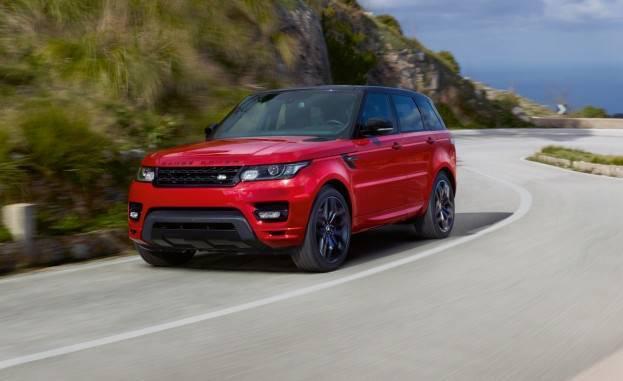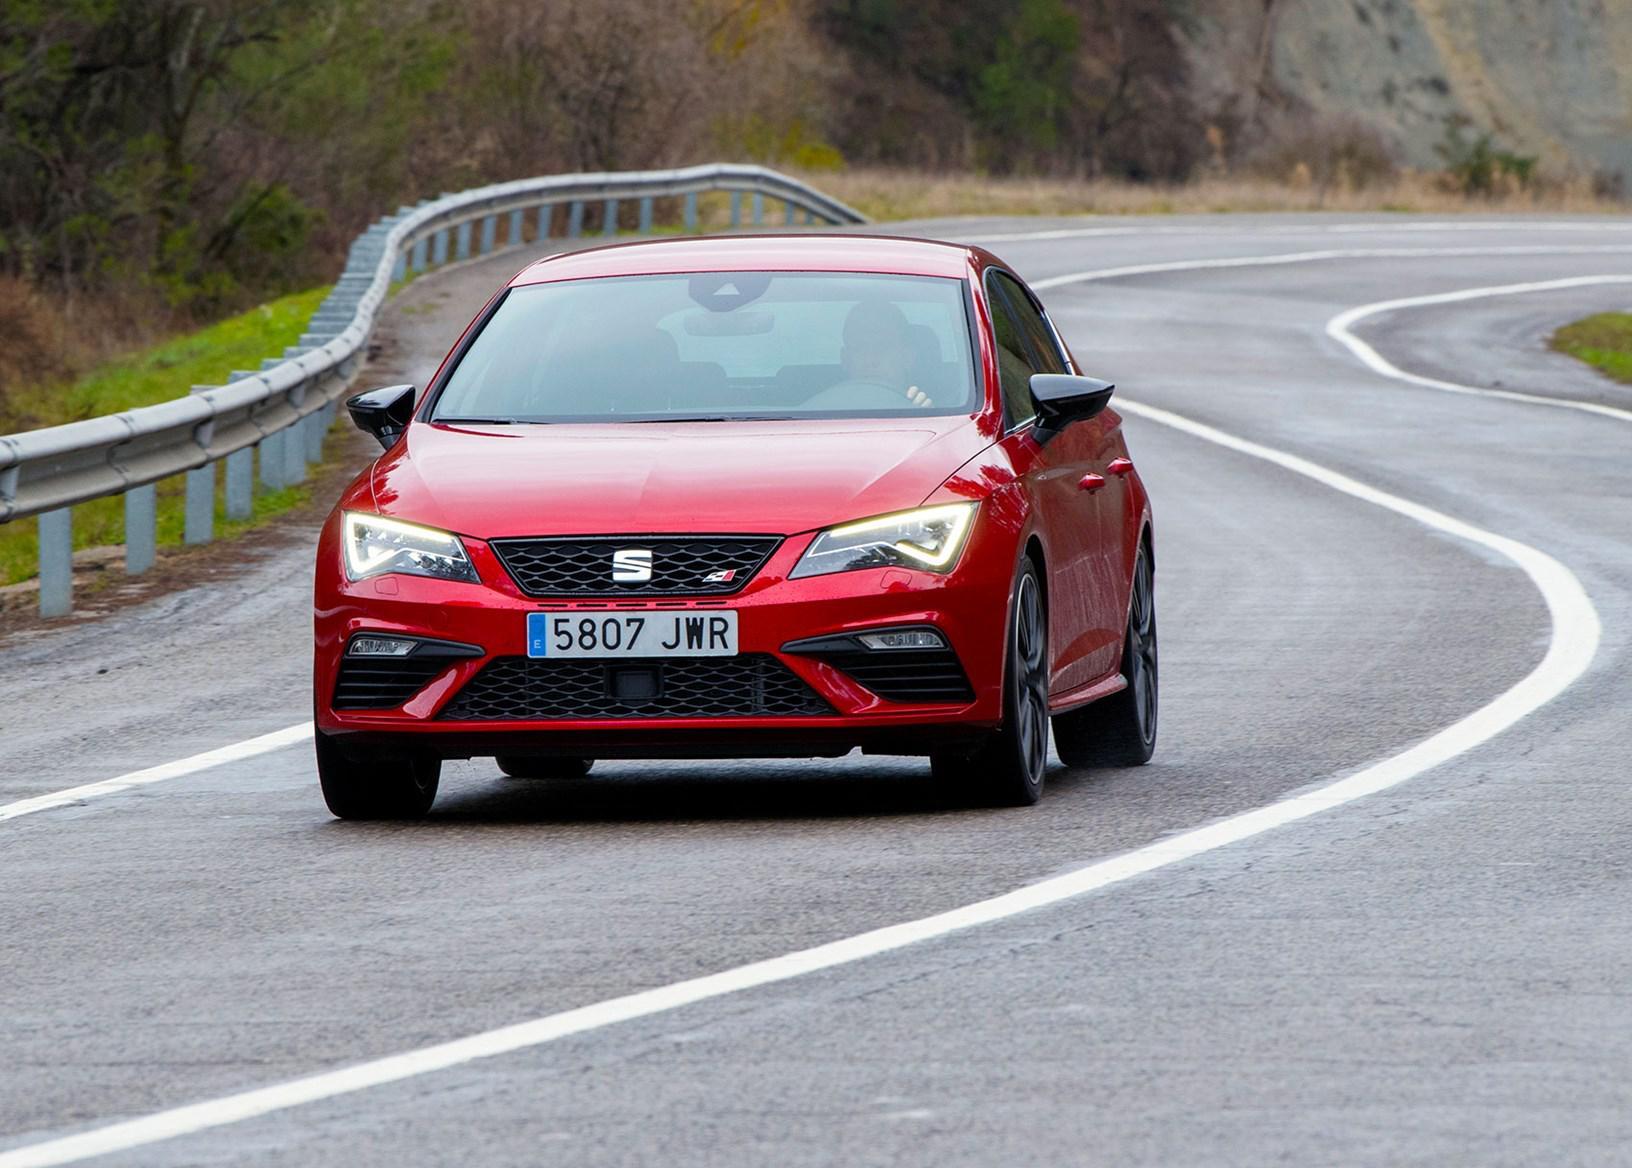The first image is the image on the left, the second image is the image on the right. Analyze the images presented: Is the assertion "There are two cars being driven on roads." valid? Answer yes or no. Yes. The first image is the image on the left, the second image is the image on the right. For the images displayed, is the sentence "The left image contains two cars including one blue one, and the right image includes a dark red convertible with its top down." factually correct? Answer yes or no. No. 